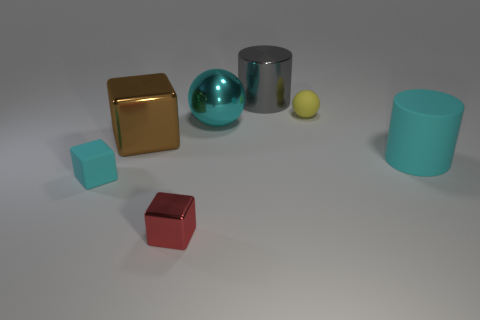Subtract all small cubes. How many cubes are left? 1 Subtract all brown blocks. How many blocks are left? 2 Add 3 big brown rubber things. How many objects exist? 10 Subtract all cylinders. How many objects are left? 5 Subtract 2 cylinders. How many cylinders are left? 0 Subtract all cyan spheres. How many brown cylinders are left? 0 Add 2 cyan metallic things. How many cyan metallic things exist? 3 Subtract 0 purple cylinders. How many objects are left? 7 Subtract all blue balls. Subtract all yellow blocks. How many balls are left? 2 Subtract all large metal things. Subtract all big yellow rubber objects. How many objects are left? 4 